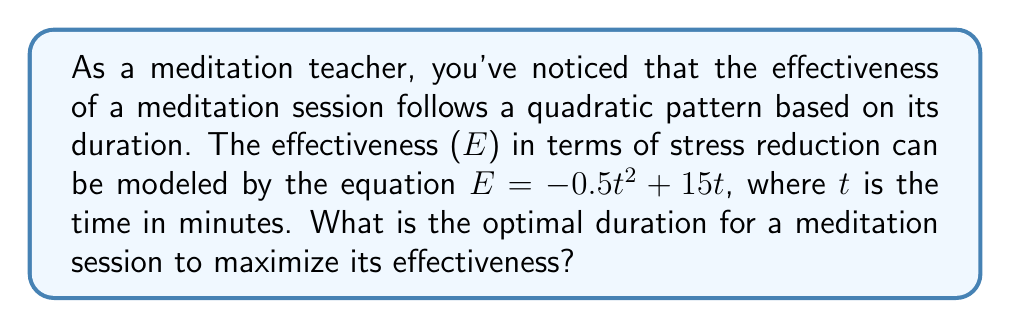Help me with this question. To find the optimal duration for the meditation session, we need to determine the maximum point of the quadratic function. Here's how we can do this:

1. The equation given is $E = -0.5t^2 + 15t$, which is in the form $f(t) = at^2 + bt + c$ where $a = -0.5$, $b = 15$, and $c = 0$.

2. For a quadratic function, the t-coordinate of the vertex (which represents the optimal time in this case) can be found using the formula: $t = -\frac{b}{2a}$

3. Substituting our values:
   $t = -\frac{15}{2(-0.5)} = -\frac{15}{-1} = 15$

4. To verify this is a maximum (not a minimum), we can check that $a < 0$, which it is in this case.

5. Therefore, the optimal duration for a meditation session is 15 minutes.

6. If we want to find the maximum effectiveness, we can substitute t = 15 into the original equation:
   $E = -0.5(15)^2 + 15(15) = -0.5(225) + 225 = -112.5 + 225 = 112.5$

This shows that at 15 minutes, the effectiveness reaches its peak value of 112.5 units.
Answer: 15 minutes 